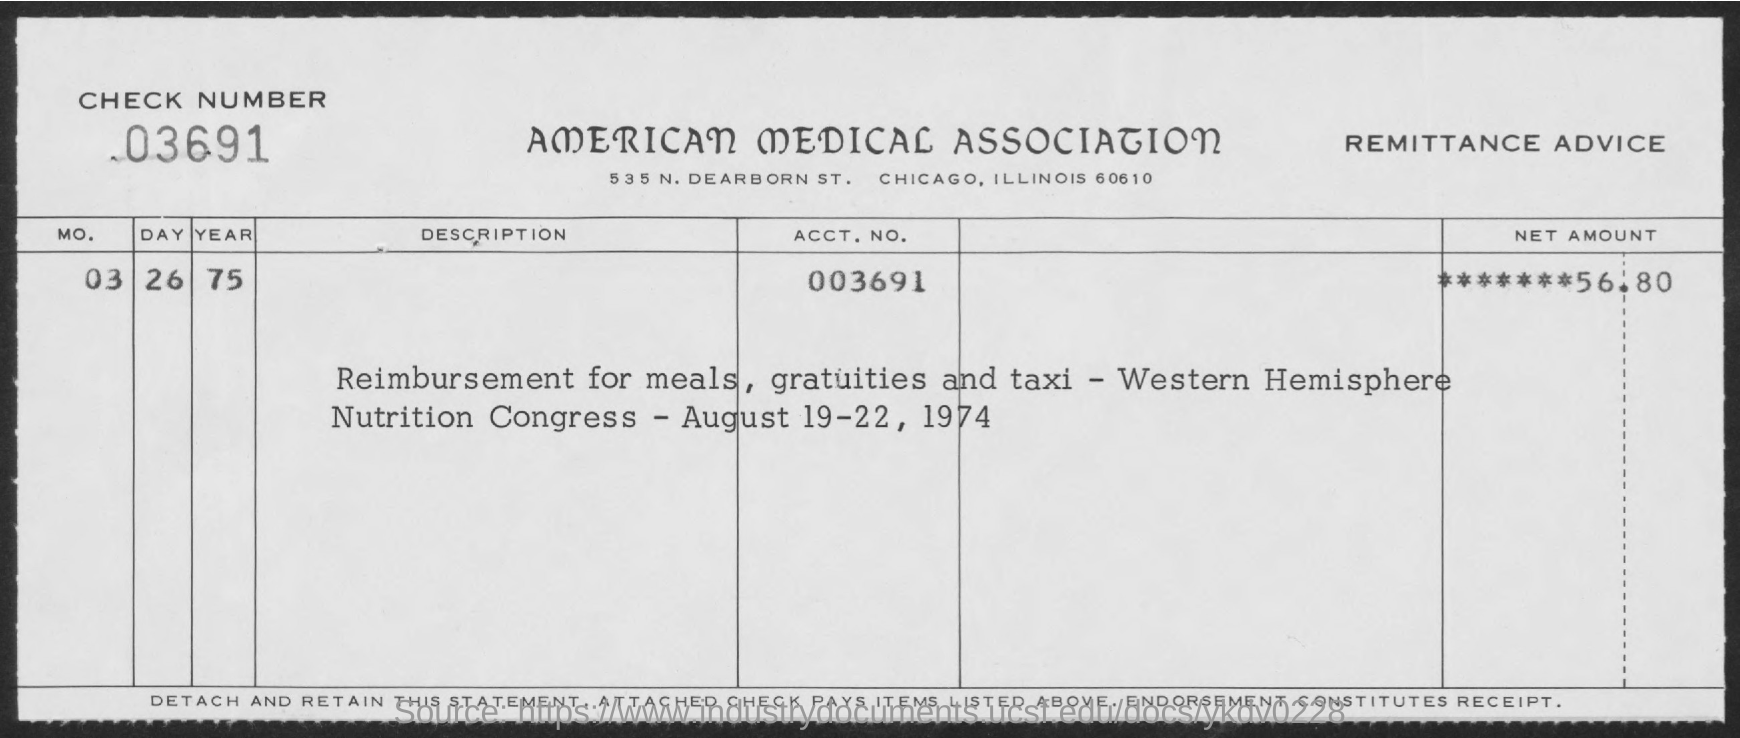Outline some significant characteristics in this image. The title of the document is "AMERICAN MEDICAL ASSOCIATION". The ACCt.NO is 003691... The check number is 03691... 